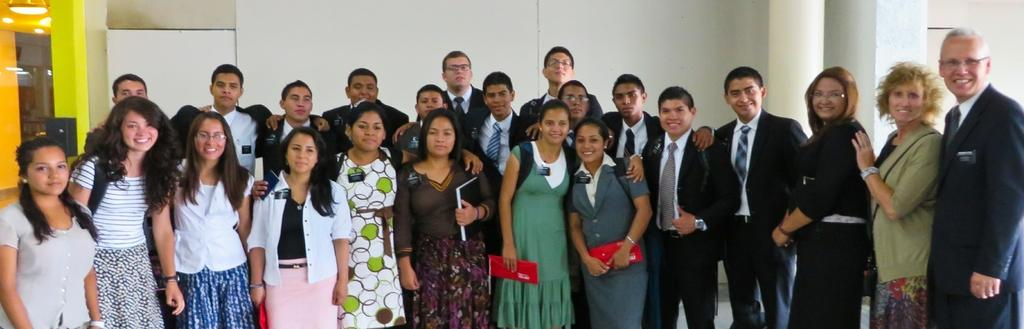Who or what can be seen in the image? There are people in the image. What is located behind the people? There is a pillar behind the people. What type of structure is present in the image? There is a wall in the image. What is on the left side of the image? There is an object on the left side of the image. What can be seen at the top of the image? There are lights visible at the top of the image. What type of club is being used by the people in the image? There is no club present in the image; the people are not holding or using any clubs. 